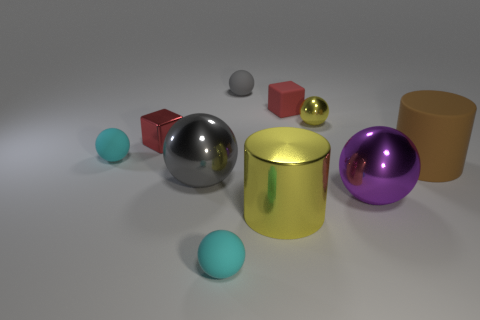There is another small metallic object that is the same shape as the tiny gray object; what color is it?
Give a very brief answer. Yellow. Is there any other thing that is the same color as the metal block?
Provide a succinct answer. Yes. There is a cylinder left of the red rubber cube that is behind the yellow object in front of the brown thing; how big is it?
Keep it short and to the point. Large. The small object that is both behind the red metal thing and left of the large yellow thing is what color?
Provide a short and direct response. Gray. How big is the red cube that is left of the tiny rubber block?
Provide a succinct answer. Small. What number of big balls are the same material as the purple thing?
Your response must be concise. 1. There is a metallic thing that is the same color as the big shiny cylinder; what is its shape?
Provide a succinct answer. Sphere. Do the yellow metallic object in front of the small yellow ball and the purple thing have the same shape?
Your answer should be very brief. No. What color is the small block that is the same material as the small gray object?
Your answer should be compact. Red. Are there any big brown rubber things to the left of the small red thing right of the big cylinder in front of the purple metallic object?
Provide a short and direct response. No. 